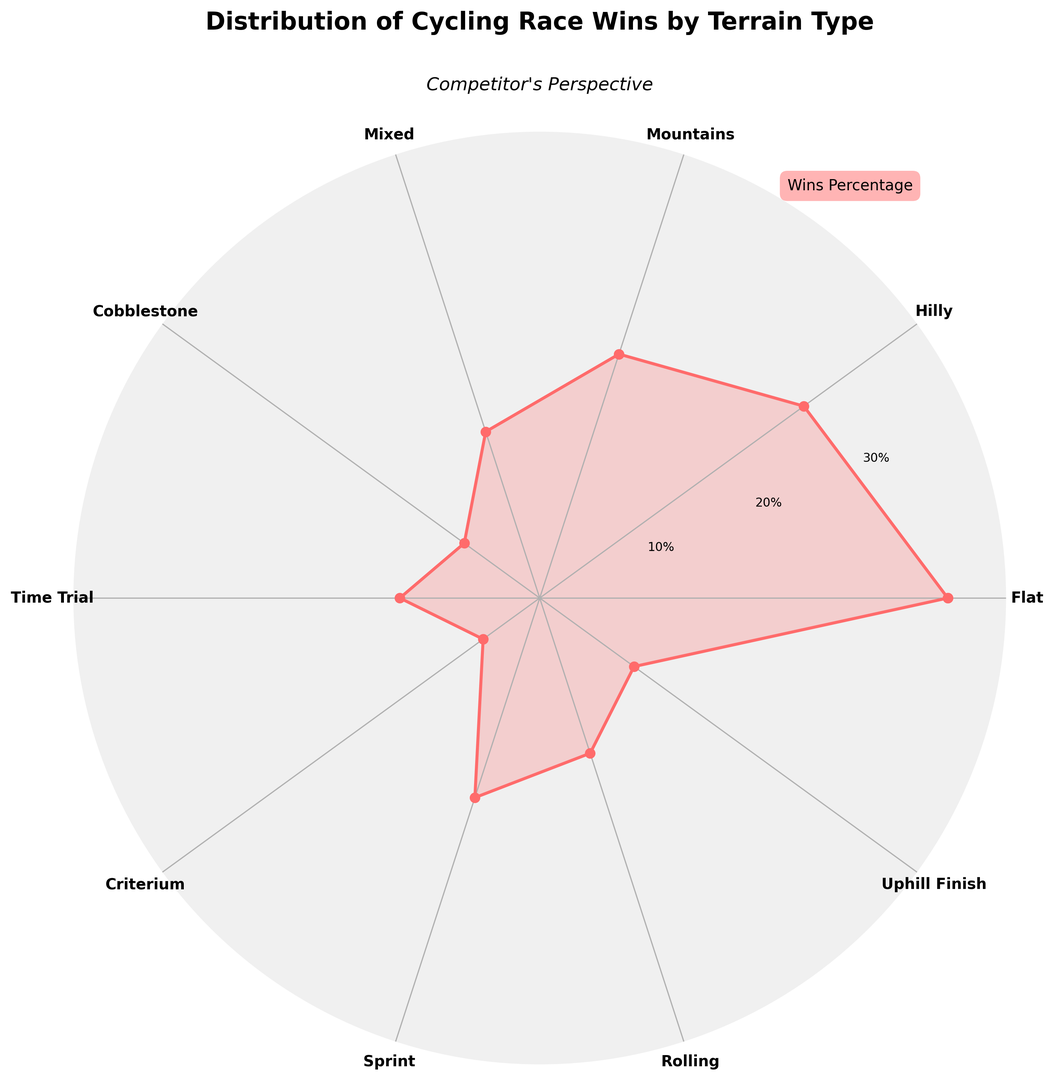What percentage of race wins are from flat terrain? To find the percentage of wins from flat terrain, look at the corresponding segment on the rose chart labeled "Flat". It shows 35%.
Answer: 35% Which terrain type has the highest percentage of race wins? Examine the length of each segment on the rose chart. The "Flat" segment is the longest, indicating it has the highest percentage.
Answer: Flat How much higher is the percentage of wins on flat terrain compared to mountainous terrain? Find the percentages for flat and mountainous terrains (35% and 22% respectively). Subtract the latter from the former: 35% - 22% = 13%.
Answer: 13% What is the total percentage of wins for hilly and rolling terrain combined? Locate the percentages for hilly (28%) and rolling (14%) terrains. Add these values together: 28% + 14% = 42%.
Answer: 42% What seems to be weakest terrain type based on race wins? Identify the terrain type with the smallest segment in the rose chart, which is "Criterium" at 6%.
Answer: Criterium Does the percentage of wins for sprint terrain exceed 15%? Check the segment labeled "Sprint" on the rose chart which shows 18%. Since 18% > 15%, the statement is true.
Answer: Yes Which terrain type has more wins, cobblestone or time trial? Compare the segments for cobblestone (8%) and time trial (12%). Time trial is higher.
Answer: Time Trial What is the percentage difference between mixed terrain wins and uphill finish wins? Find the percentages of mixed (15%) and uphill finish (10%) terrains. Subtract the smaller percentage from the larger one: 15% - 10% = 5%.
Answer: 5% How does the visual appearance of wins distribution change from flat to hilly terrain? Observe the transition from the flat segment (35%) to the hilly segment (28%). The hilly segment is shorter, indicating fewer wins compared to flat terrain.
Answer: The hilly terrain has fewer wins What is the combined percentage of wins for sprint, time trial, and criterium terrains? Find the percentages for sprint (18%), time trial (12%), and criterium (6%). Add them: 18% + 12% + 6% = 36%.
Answer: 36% 